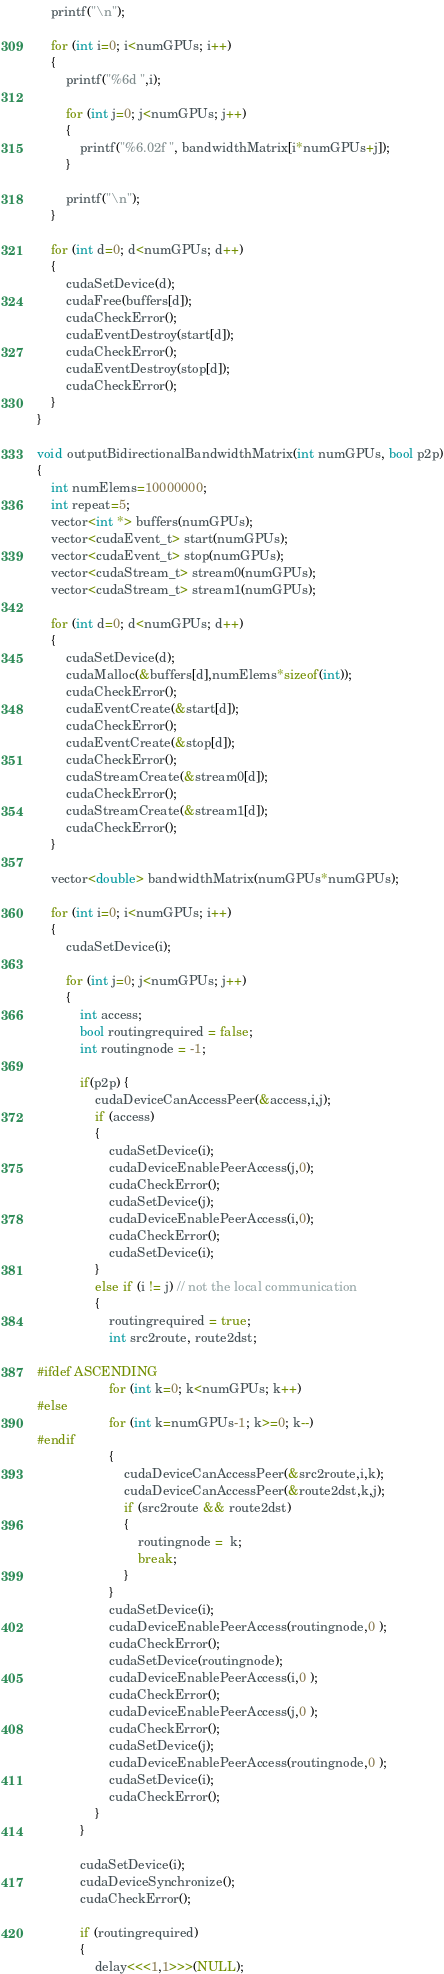Convert code to text. <code><loc_0><loc_0><loc_500><loc_500><_Cuda_>    printf("\n");

    for (int i=0; i<numGPUs; i++)
    {
        printf("%6d ",i);

        for (int j=0; j<numGPUs; j++)
        {
            printf("%6.02f ", bandwidthMatrix[i*numGPUs+j]);
        }

        printf("\n");
    }

    for (int d=0; d<numGPUs; d++)
    {
        cudaSetDevice(d);
        cudaFree(buffers[d]);
        cudaCheckError();
        cudaEventDestroy(start[d]);
        cudaCheckError();
        cudaEventDestroy(stop[d]);
        cudaCheckError();
    }
}

void outputBidirectionalBandwidthMatrix(int numGPUs, bool p2p)
{
    int numElems=10000000;
    int repeat=5;
    vector<int *> buffers(numGPUs);
    vector<cudaEvent_t> start(numGPUs);
    vector<cudaEvent_t> stop(numGPUs);
    vector<cudaStream_t> stream0(numGPUs);
    vector<cudaStream_t> stream1(numGPUs);

    for (int d=0; d<numGPUs; d++)
    {
        cudaSetDevice(d);
        cudaMalloc(&buffers[d],numElems*sizeof(int));
        cudaCheckError();
        cudaEventCreate(&start[d]);
        cudaCheckError();
        cudaEventCreate(&stop[d]);
        cudaCheckError();
        cudaStreamCreate(&stream0[d]);
        cudaCheckError();
        cudaStreamCreate(&stream1[d]);
        cudaCheckError();
    }

    vector<double> bandwidthMatrix(numGPUs*numGPUs);

    for (int i=0; i<numGPUs; i++)
    {
        cudaSetDevice(i);

        for (int j=0; j<numGPUs; j++)
        {
            int access;
            bool routingrequired = false;
            int routingnode = -1;

            if(p2p) {
                cudaDeviceCanAccessPeer(&access,i,j);
                if (access)
                {
                    cudaSetDevice(i);
                    cudaDeviceEnablePeerAccess(j,0);
                    cudaCheckError();
                    cudaSetDevice(j);
                    cudaDeviceEnablePeerAccess(i,0);
                    cudaCheckError();
                    cudaSetDevice(i);
                }
                else if (i != j) // not the local communication
                {
                    routingrequired = true;
                    int src2route, route2dst;

#ifdef ASCENDING
                    for (int k=0; k<numGPUs; k++)
#else
                    for (int k=numGPUs-1; k>=0; k--)
#endif
                    {
                        cudaDeviceCanAccessPeer(&src2route,i,k);
                        cudaDeviceCanAccessPeer(&route2dst,k,j);
                        if (src2route && route2dst)
                        {
                            routingnode =  k;
                            break;
                        }
                    }
                    cudaSetDevice(i);
                    cudaDeviceEnablePeerAccess(routingnode,0 );
                    cudaCheckError();
                    cudaSetDevice(routingnode);
                    cudaDeviceEnablePeerAccess(i,0 );
                    cudaCheckError();
                    cudaDeviceEnablePeerAccess(j,0 );
                    cudaCheckError();
                    cudaSetDevice(j);
                    cudaDeviceEnablePeerAccess(routingnode,0 );
                    cudaSetDevice(i);
                    cudaCheckError();
                }
            }

            cudaSetDevice(i);
            cudaDeviceSynchronize();
            cudaCheckError();

            if (routingrequired)
            {
                delay<<<1,1>>>(NULL);</code> 